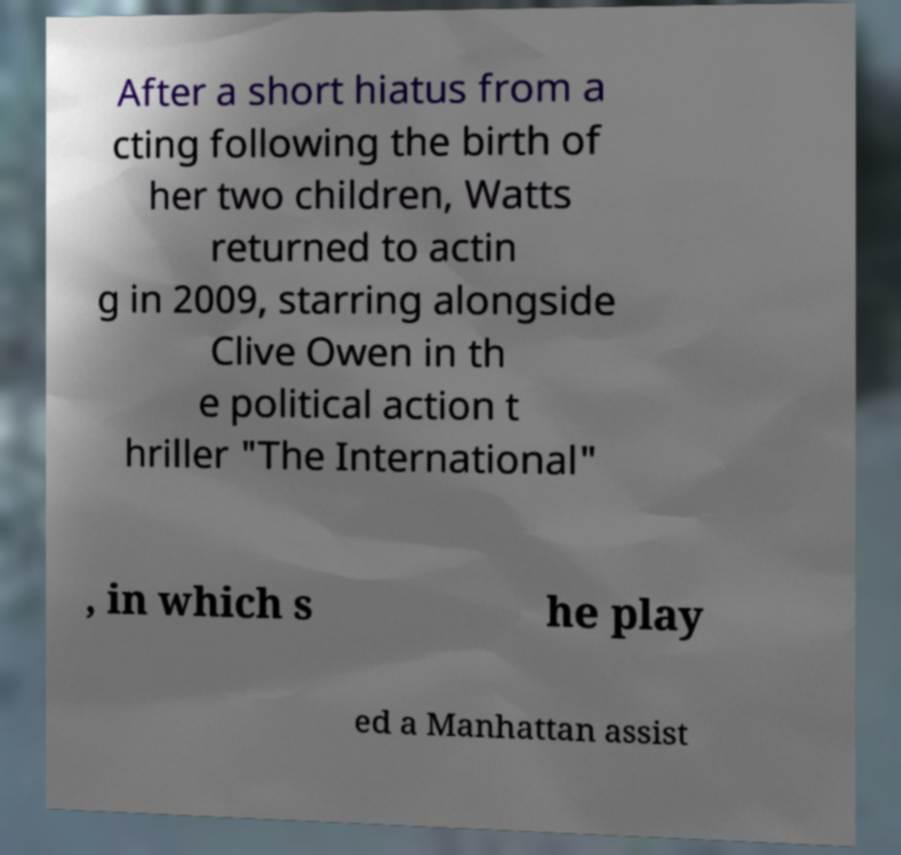Could you extract and type out the text from this image? After a short hiatus from a cting following the birth of her two children, Watts returned to actin g in 2009, starring alongside Clive Owen in th e political action t hriller "The International" , in which s he play ed a Manhattan assist 